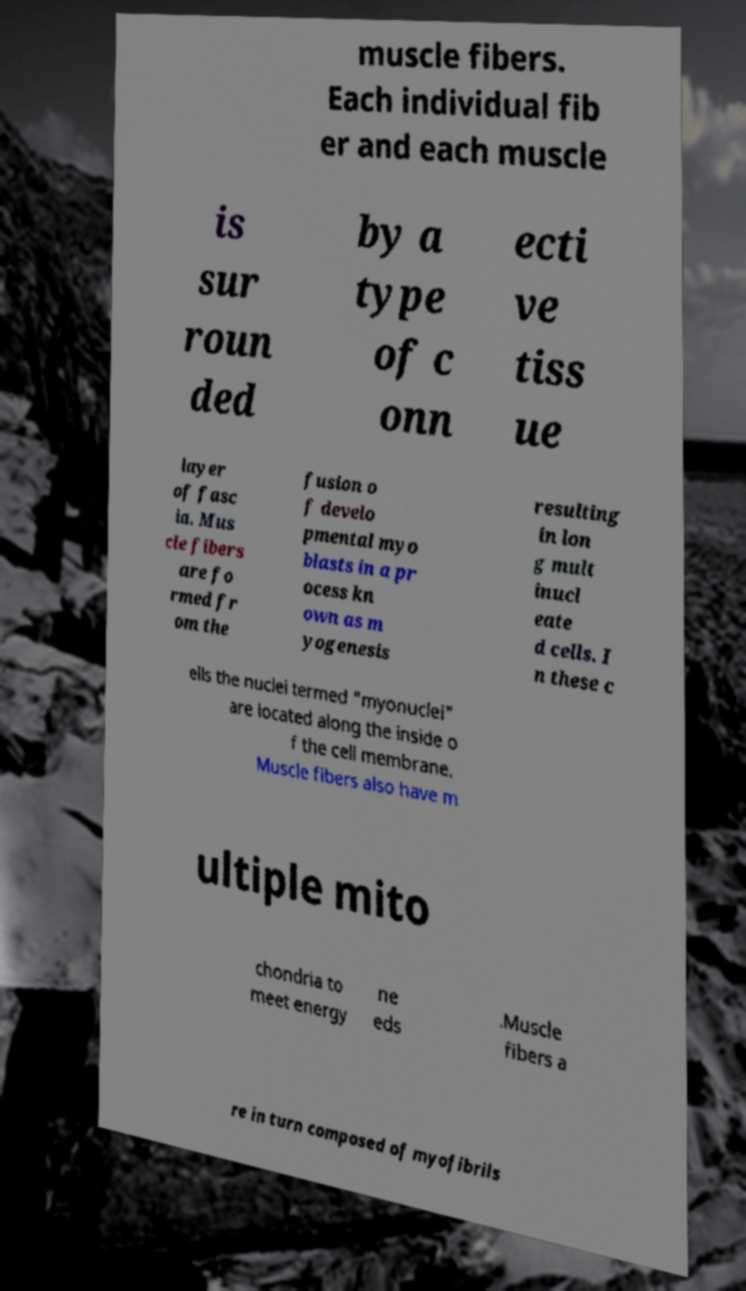Could you extract and type out the text from this image? muscle fibers. Each individual fib er and each muscle is sur roun ded by a type of c onn ecti ve tiss ue layer of fasc ia. Mus cle fibers are fo rmed fr om the fusion o f develo pmental myo blasts in a pr ocess kn own as m yogenesis resulting in lon g mult inucl eate d cells. I n these c ells the nuclei termed "myonuclei" are located along the inside o f the cell membrane. Muscle fibers also have m ultiple mito chondria to meet energy ne eds .Muscle fibers a re in turn composed of myofibrils 